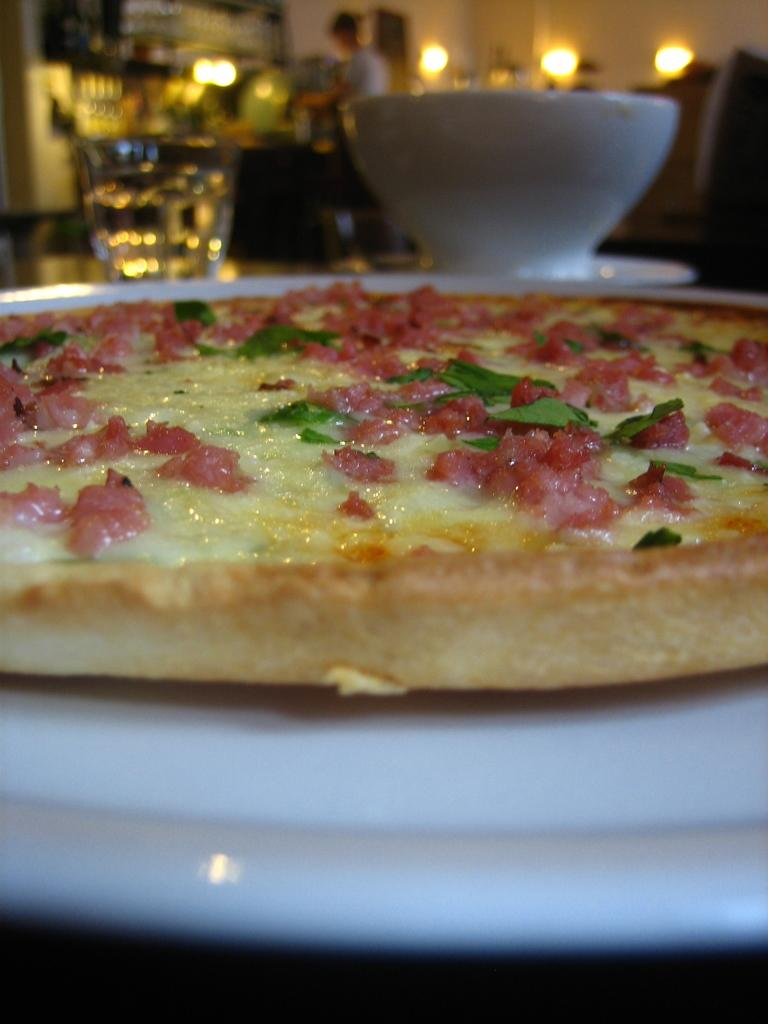What type of food is visible in the image? There is a pizza in the image. How is the pizza presented? The pizza is placed on a plate. What other items can be seen in the image? There is a bowl and a glass of water in the image. Can you describe the background of the image? There is a person and lights in the background of the image. What type of gold jewelry is the person wearing in the image? There is no person wearing gold jewelry in the image; the person in the background is not described as wearing any jewelry. 